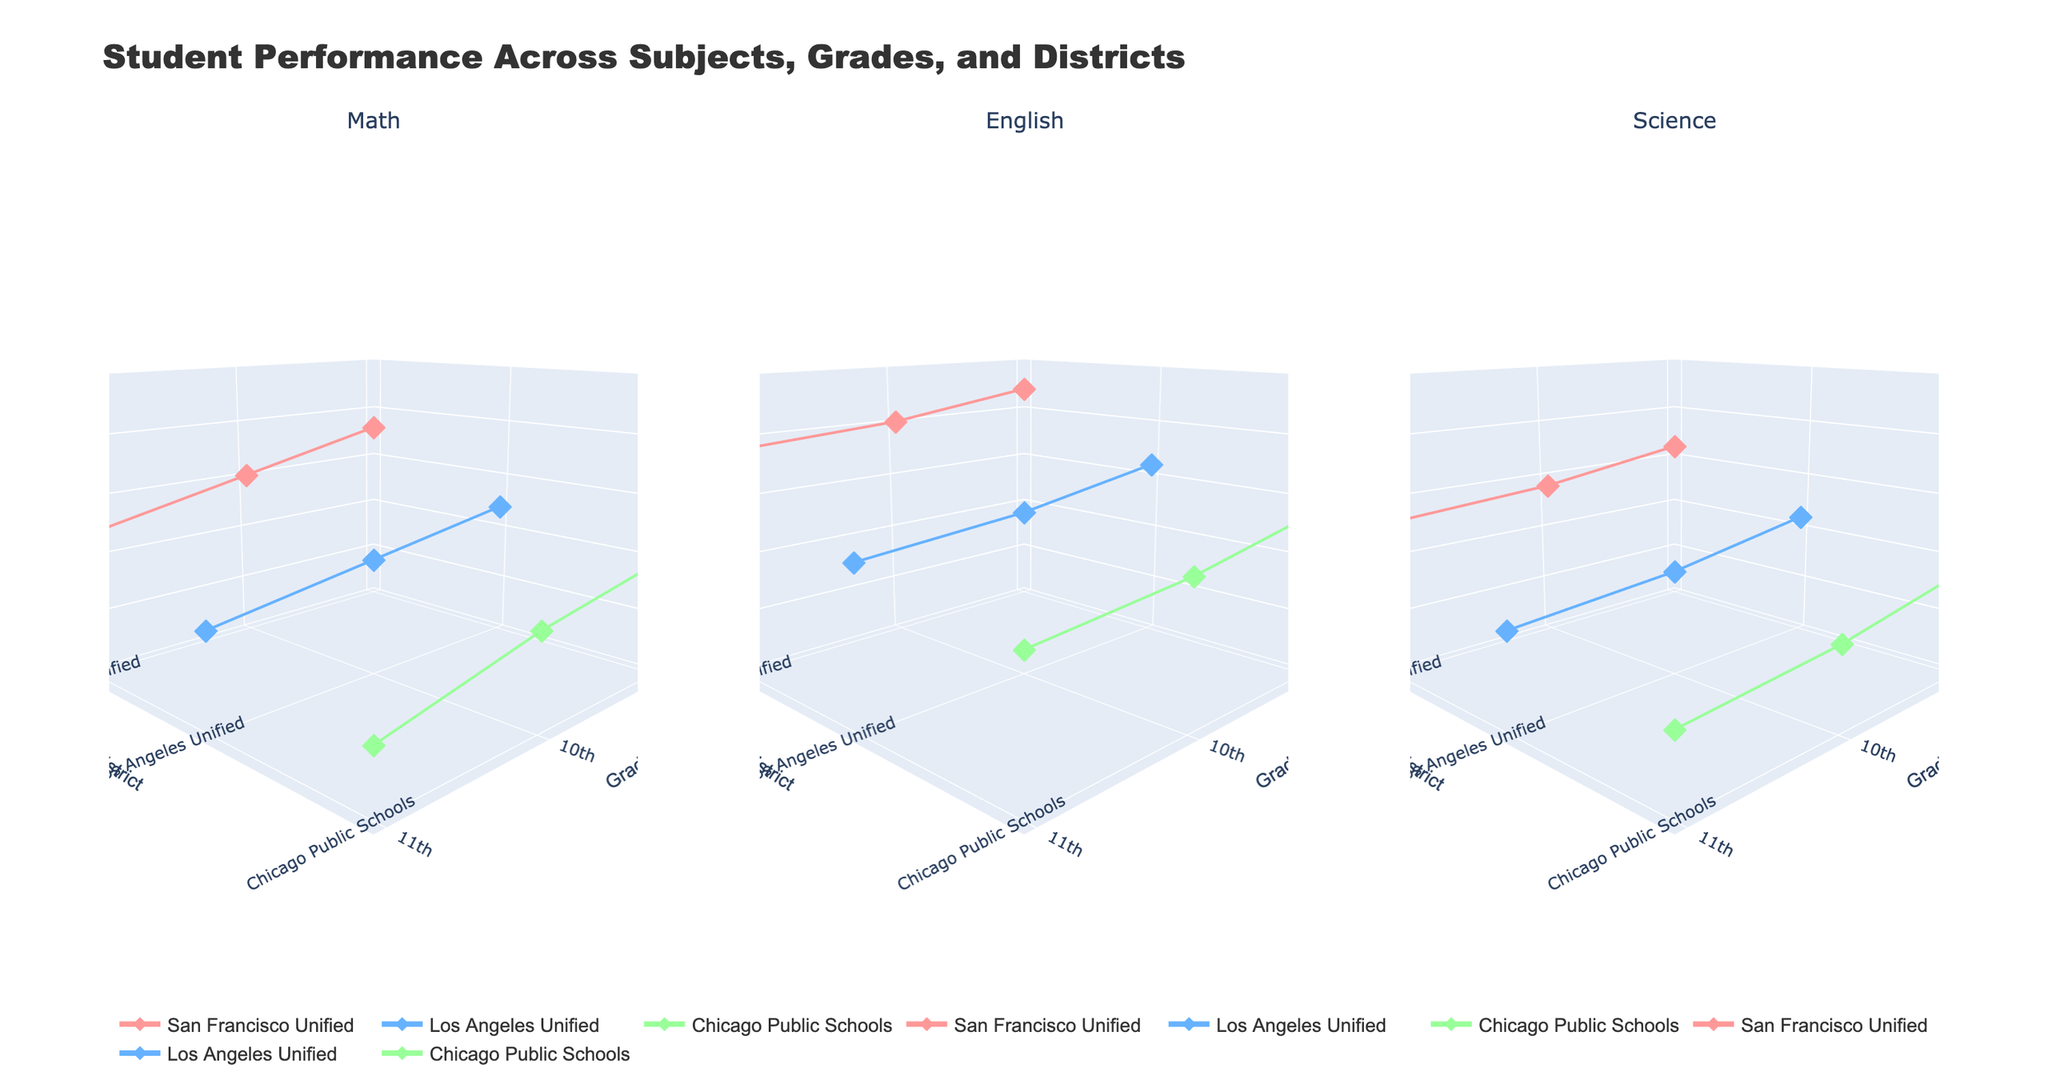What is the title of the figure? The title is shown at the top of the figure in a prominent font. It provides a summary of the information presented in the plots.
Answer: Student Performance Across Subjects, Grades, and Districts Which district has the highest average score in English for 9th grade? Look at the subplot for English and find the 9th-grade scores for each district. The highest point is the one with the highest score.
Answer: San Francisco Unified Which subject shows the smallest decline in average scores from 9th to 11th grade in Chicago Public Schools? Compare the decline in average scores from 9th to 11th grade for each subject in the plot. Calculate the difference and identify the smallest.
Answer: English In which grade do students from Los Angeles Unified perform the worst in Science? Go to the Science subplot, locate the Los Angeles Unified data points for each grade, and identify the point with the lowest average score.
Answer: 11th grade How do the average Math scores in San Francisco Unified compare across grades? Identify the Math scores for San Francisco Unified in the Math subplot, observe how the scores change across grades.
Answer: Declines from 9th to 11th grade What is the difference in the average score between 9th and 11th grade Math students in Los Angeles Unified? In the Math subplot, locate the average scores for Los Angeles Unified for both 9th and 11th grades, and calculate the difference.
Answer: 4 points Which district shows the most consistent performance across grades in Science? Evaluate the Science subplot and see which district has the least variation in scores across grades.
Answer: San Francisco Unified Compare the average scores of 10th grade students across all subjects in Chicago Public Schools. Which subject do they perform best in? For each subplot, find the 10th grade average score for Chicago Public Schools and compare them to identify the highest.
Answer: English Which subject has the largest range of average scores across districts in 9th grade? For each subject's subplot, look at the 9th-grade scores and determine the range (difference between the highest and lowest score). Identify the subject with the largest range.
Answer: English 